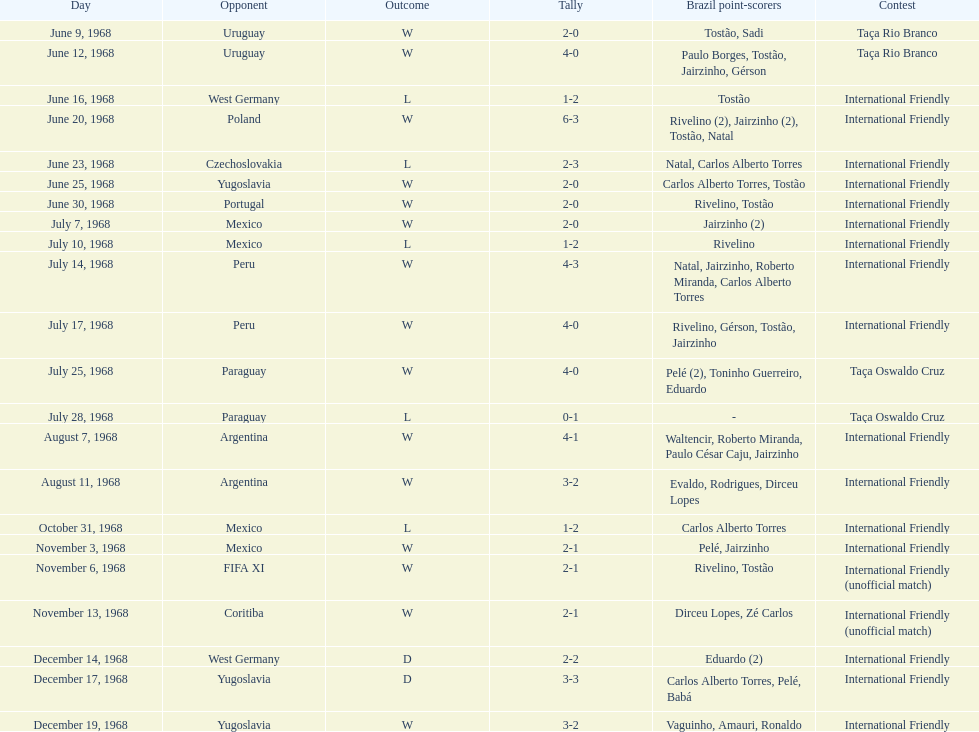What is the number of countries they have played? 11. 